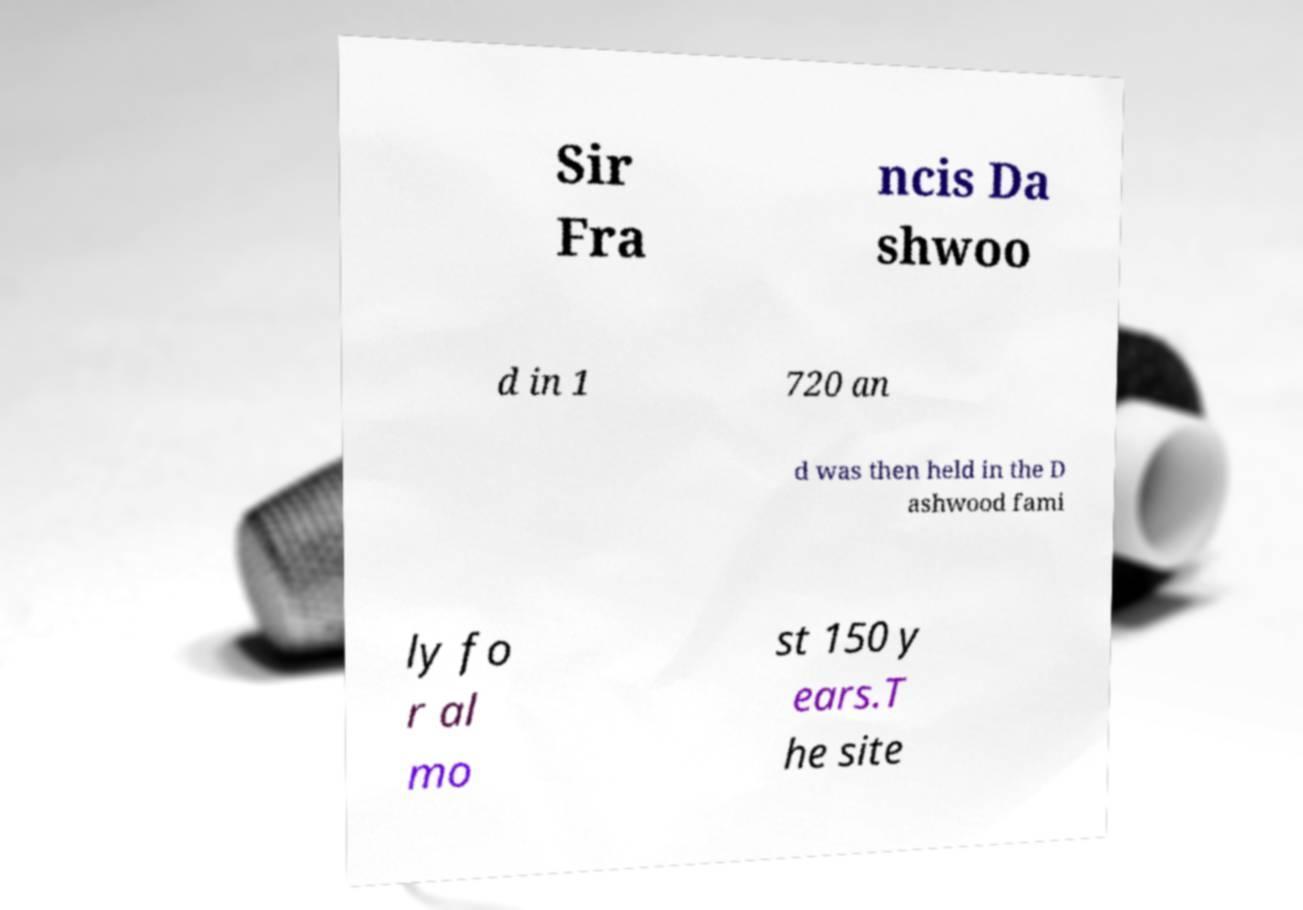What messages or text are displayed in this image? I need them in a readable, typed format. Sir Fra ncis Da shwoo d in 1 720 an d was then held in the D ashwood fami ly fo r al mo st 150 y ears.T he site 